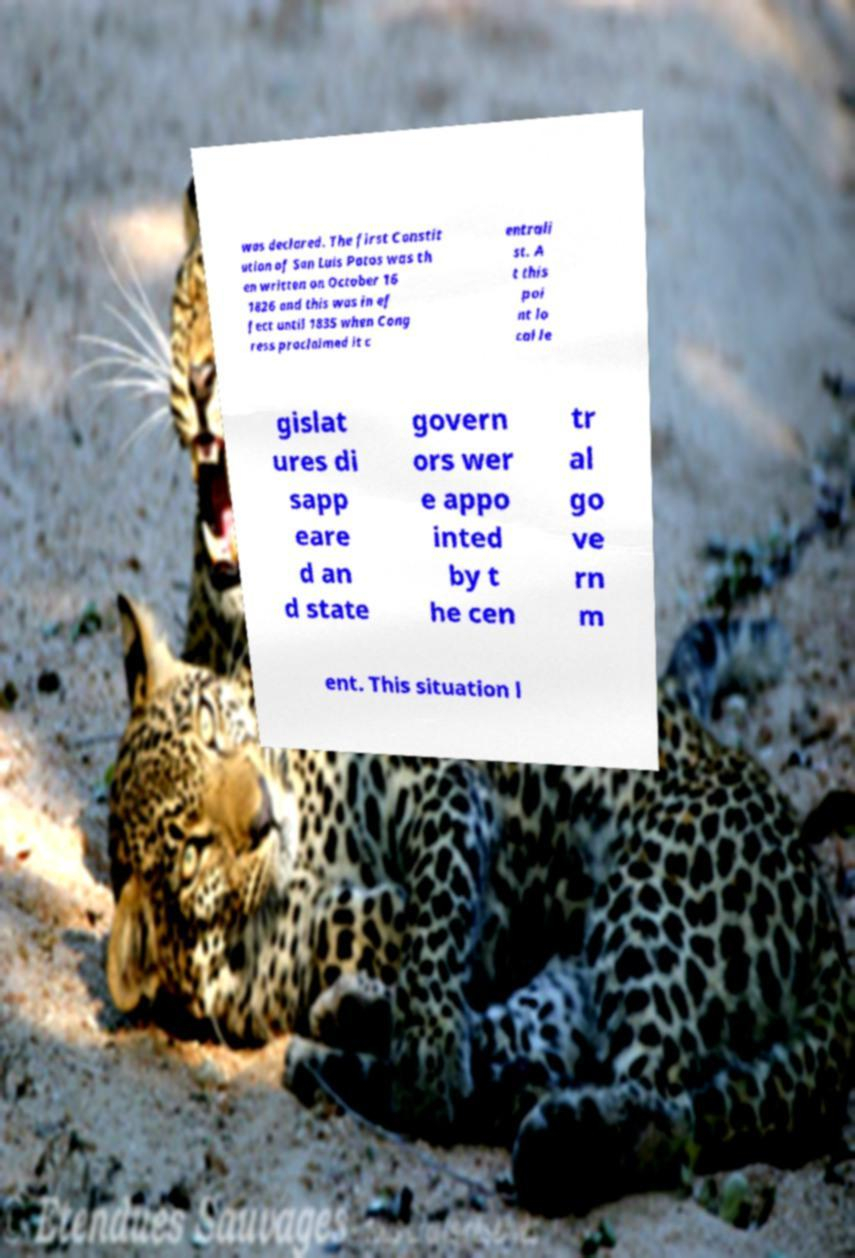Can you accurately transcribe the text from the provided image for me? was declared. The first Constit ution of San Luis Potos was th en written on October 16 1826 and this was in ef fect until 1835 when Cong ress proclaimed it c entrali st. A t this poi nt lo cal le gislat ures di sapp eare d an d state govern ors wer e appo inted by t he cen tr al go ve rn m ent. This situation l 